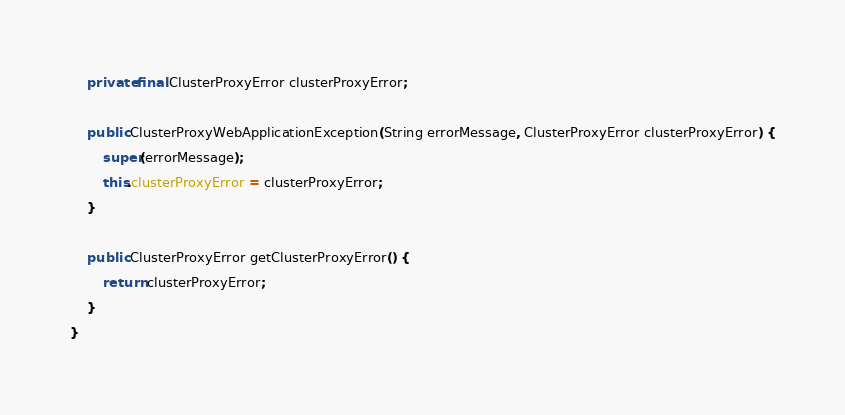<code> <loc_0><loc_0><loc_500><loc_500><_Java_>    private final ClusterProxyError clusterProxyError;

    public ClusterProxyWebApplicationException(String errorMessage, ClusterProxyError clusterProxyError) {
        super(errorMessage);
        this.clusterProxyError = clusterProxyError;
    }

    public ClusterProxyError getClusterProxyError() {
        return clusterProxyError;
    }
}
</code> 